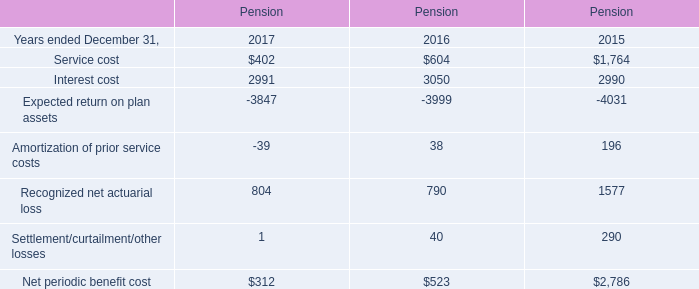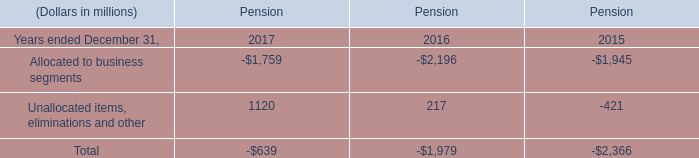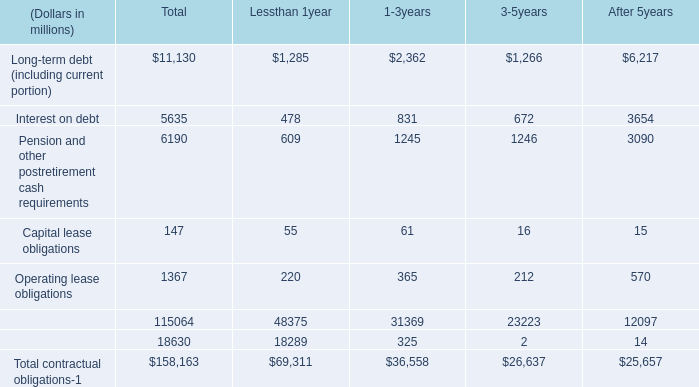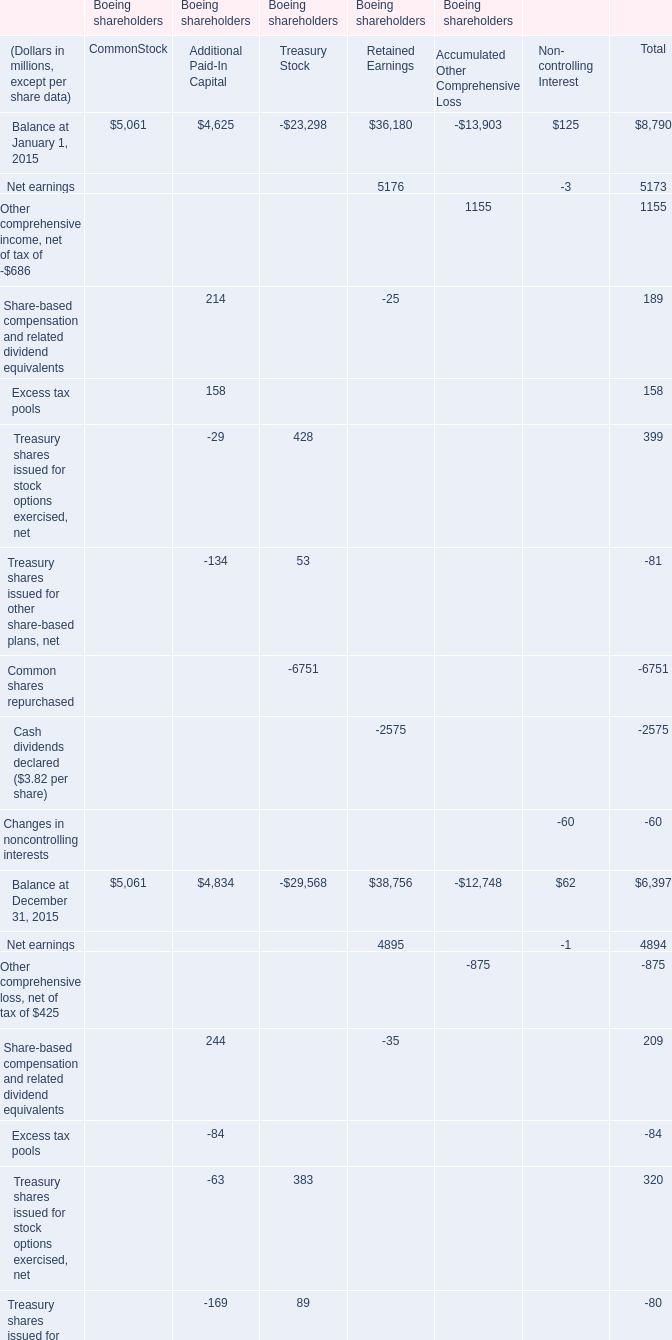What is the sum of Unallocated items, eliminations and other in 2015 and Operating lease obligations in After 5 years? (in million) 
Computations: (-421 + 570)
Answer: 149.0. 